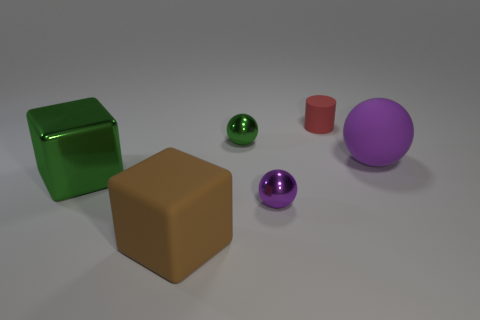Subtract all tiny balls. How many balls are left? 1 Add 1 big brown matte blocks. How many objects exist? 7 Subtract all green balls. How many balls are left? 2 Subtract all cylinders. How many objects are left? 5 Subtract 1 cylinders. How many cylinders are left? 0 Subtract all purple cylinders. How many purple balls are left? 2 Add 5 brown objects. How many brown objects exist? 6 Subtract 0 brown balls. How many objects are left? 6 Subtract all brown blocks. Subtract all gray balls. How many blocks are left? 1 Subtract all purple metal blocks. Subtract all purple balls. How many objects are left? 4 